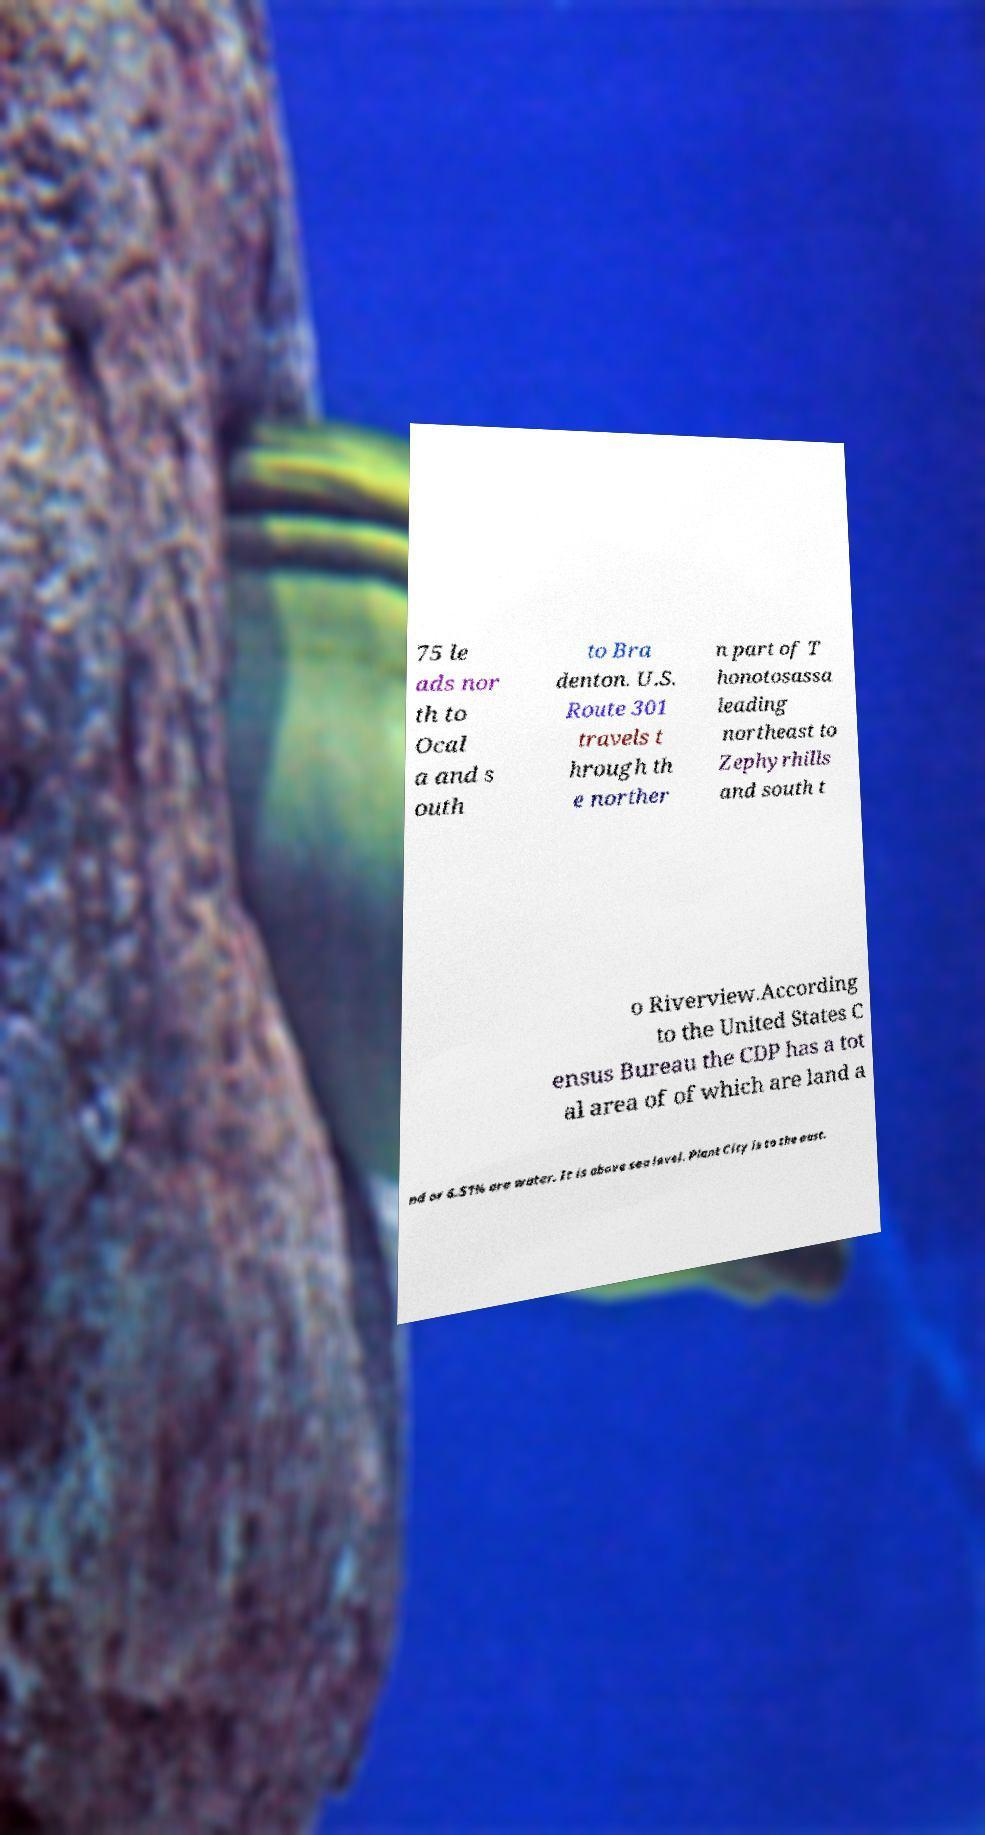There's text embedded in this image that I need extracted. Can you transcribe it verbatim? 75 le ads nor th to Ocal a and s outh to Bra denton. U.S. Route 301 travels t hrough th e norther n part of T honotosassa leading northeast to Zephyrhills and south t o Riverview.According to the United States C ensus Bureau the CDP has a tot al area of of which are land a nd or 6.51% are water. It is above sea level. Plant City is to the east. 